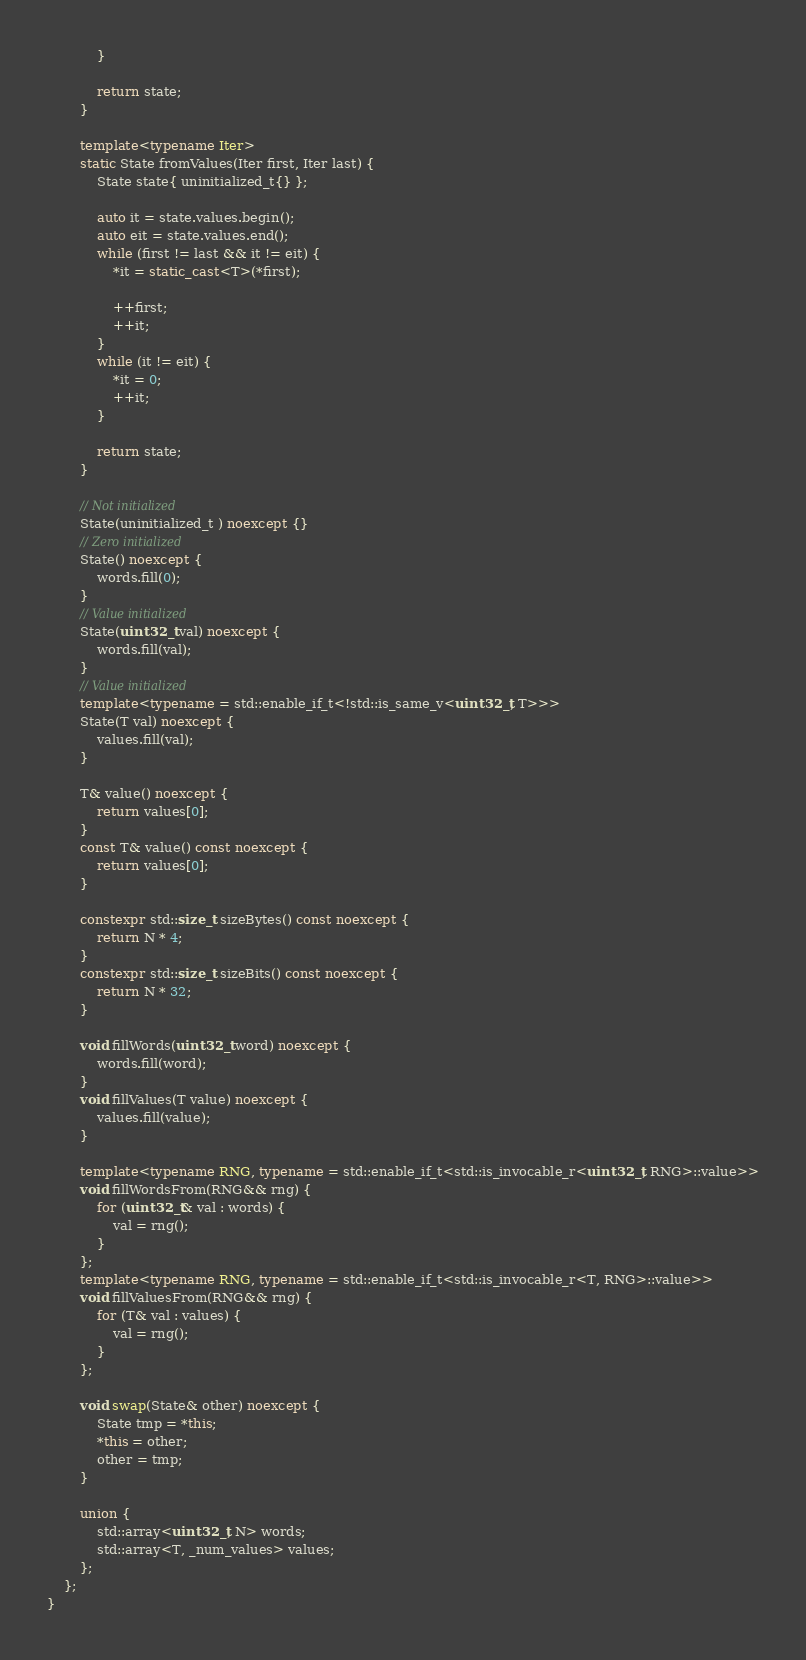<code> <loc_0><loc_0><loc_500><loc_500><_C++_>			}

			return state;
		}

		template<typename Iter>
		static State fromValues(Iter first, Iter last) {
			State state{ uninitialized_t{} };

			auto it = state.values.begin();
			auto eit = state.values.end();
			while (first != last && it != eit) {
				*it = static_cast<T>(*first);

				++first;
				++it;
			}
			while (it != eit) {
				*it = 0;
				++it;
			}

			return state;
		}

		// Not initialized
		State(uninitialized_t ) noexcept {}
		// Zero initialized
		State() noexcept {
			words.fill(0);
		}
		// Value initialized
		State(uint32_t val) noexcept {
			words.fill(val);
		}
		// Value initialized
		template<typename = std::enable_if_t<!std::is_same_v<uint32_t, T>>>
		State(T val) noexcept {
			values.fill(val);
		}

		T& value() noexcept {
			return values[0];
		}
		const T& value() const noexcept {
			return values[0];
		}

		constexpr std::size_t sizeBytes() const noexcept {
			return N * 4;
		}
		constexpr std::size_t sizeBits() const noexcept {
			return N * 32;
		}

		void fillWords(uint32_t word) noexcept {
			words.fill(word);
		}
		void fillValues(T value) noexcept {
			values.fill(value);
		}

		template<typename RNG, typename = std::enable_if_t<std::is_invocable_r<uint32_t, RNG>::value>>
		void fillWordsFrom(RNG&& rng) {
			for (uint32_t& val : words) {
				val = rng();
			}
		};
		template<typename RNG, typename = std::enable_if_t<std::is_invocable_r<T, RNG>::value>>
		void fillValuesFrom(RNG&& rng) {
			for (T& val : values) {
				val = rng();
			}
		};

		void swap(State& other) noexcept {
			State tmp = *this;
			*this = other;
			other = tmp;
		}
	
		union {
			std::array<uint32_t, N> words;
			std::array<T, _num_values> values;
		};
	};
}</code> 